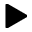<formula> <loc_0><loc_0><loc_500><loc_500>\blacktriangleright</formula> 